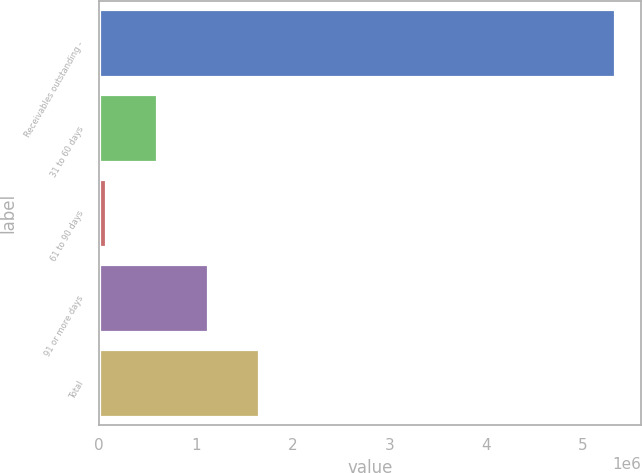<chart> <loc_0><loc_0><loc_500><loc_500><bar_chart><fcel>Receivables outstanding -<fcel>31 to 60 days<fcel>61 to 90 days<fcel>91 or more days<fcel>Total<nl><fcel>5.33278e+06<fcel>596658<fcel>70423<fcel>1.12289e+06<fcel>1.64913e+06<nl></chart> 